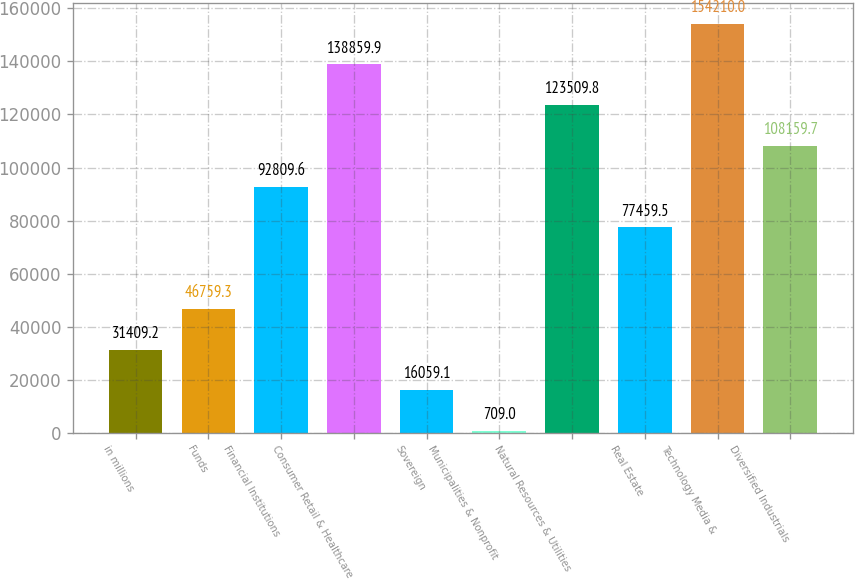Convert chart. <chart><loc_0><loc_0><loc_500><loc_500><bar_chart><fcel>in millions<fcel>Funds<fcel>Financial Institutions<fcel>Consumer Retail & Healthcare<fcel>Sovereign<fcel>Municipalities & Nonprofit<fcel>Natural Resources & Utilities<fcel>Real Estate<fcel>Technology Media &<fcel>Diversified Industrials<nl><fcel>31409.2<fcel>46759.3<fcel>92809.6<fcel>138860<fcel>16059.1<fcel>709<fcel>123510<fcel>77459.5<fcel>154210<fcel>108160<nl></chart> 